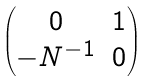Convert formula to latex. <formula><loc_0><loc_0><loc_500><loc_500>\begin{pmatrix} 0 & 1 \\ - N ^ { - 1 } & 0 \end{pmatrix}</formula> 